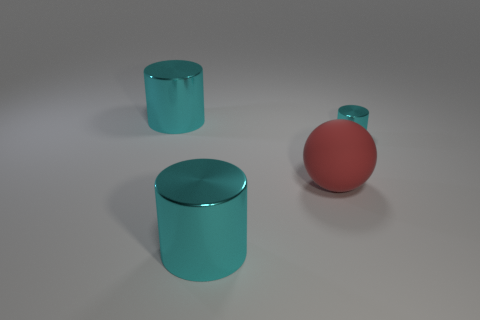Subtract all cyan cylinders. How many were subtracted if there are2cyan cylinders left? 1 Add 2 large cyan shiny cylinders. How many objects exist? 6 Subtract all cylinders. How many objects are left? 1 Subtract all small cyan metallic cylinders. Subtract all red spheres. How many objects are left? 2 Add 2 large rubber things. How many large rubber things are left? 3 Add 3 balls. How many balls exist? 4 Subtract 1 red spheres. How many objects are left? 3 